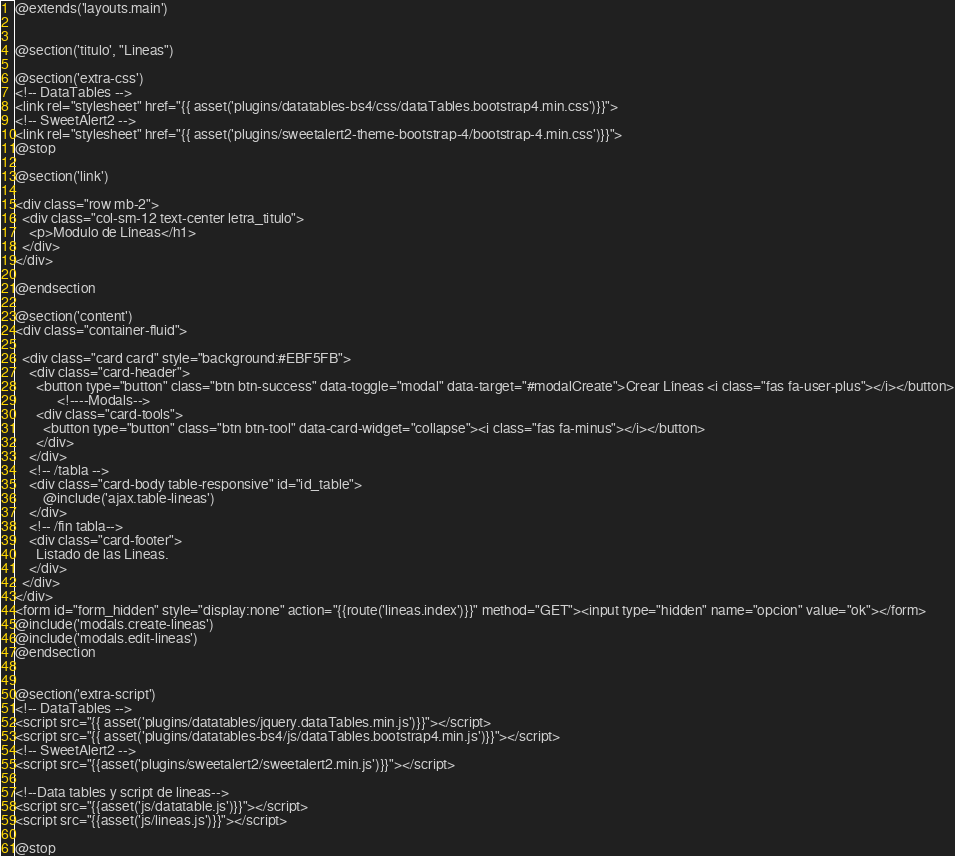Convert code to text. <code><loc_0><loc_0><loc_500><loc_500><_PHP_>@extends('layouts.main')


@section('titulo', "Lineas")

@section('extra-css')
<!-- DataTables -->
<link rel="stylesheet" href="{{ asset('plugins/datatables-bs4/css/dataTables.bootstrap4.min.css')}}">
<!-- SweetAlert2 -->
<link rel="stylesheet" href="{{ asset('plugins/sweetalert2-theme-bootstrap-4/bootstrap-4.min.css')}}">
@stop

@section('link')

<div class="row mb-2">
  <div class="col-sm-12 text-center letra_titulo">
    <p>Modulo de Líneas</h1>
  </div>
</div>

@endsection

@section('content')
<div class="container-fluid">

  <div class="card card" style="background:#EBF5FB">
    <div class="card-header">
      <button type="button" class="btn btn-success" data-toggle="modal" data-target="#modalCreate">Crear Líneas <i class="fas fa-user-plus"></i></button>
            <!----Modals-->
      <div class="card-tools">
        <button type="button" class="btn btn-tool" data-card-widget="collapse"><i class="fas fa-minus"></i></button>
      </div>
    </div>
    <!-- /tabla -->
    <div class="card-body table-responsive" id="id_table">
        @include('ajax.table-lineas')
    </div>
    <!-- /fin tabla-->
    <div class="card-footer">
      Listado de las Lineas.
    </div>
  </div>
</div>
<form id="form_hidden" style="display:none" action="{{route('lineas.index')}}" method="GET"><input type="hidden" name="opcion" value="ok"></form>
@include('modals.create-lineas')
@include('modals.edit-lineas')
@endsection


@section('extra-script')
<!-- DataTables -->
<script src="{{ asset('plugins/datatables/jquery.dataTables.min.js')}}"></script>
<script src="{{ asset('plugins/datatables-bs4/js/dataTables.bootstrap4.min.js')}}"></script>
<!-- SweetAlert2 -->
<script src="{{asset('plugins/sweetalert2/sweetalert2.min.js')}}"></script>

<!--Data tables y script de lineas-->
<script src="{{asset('js/datatable.js')}}"></script>
<script src="{{asset('js/lineas.js')}}"></script>

@stop

</code> 